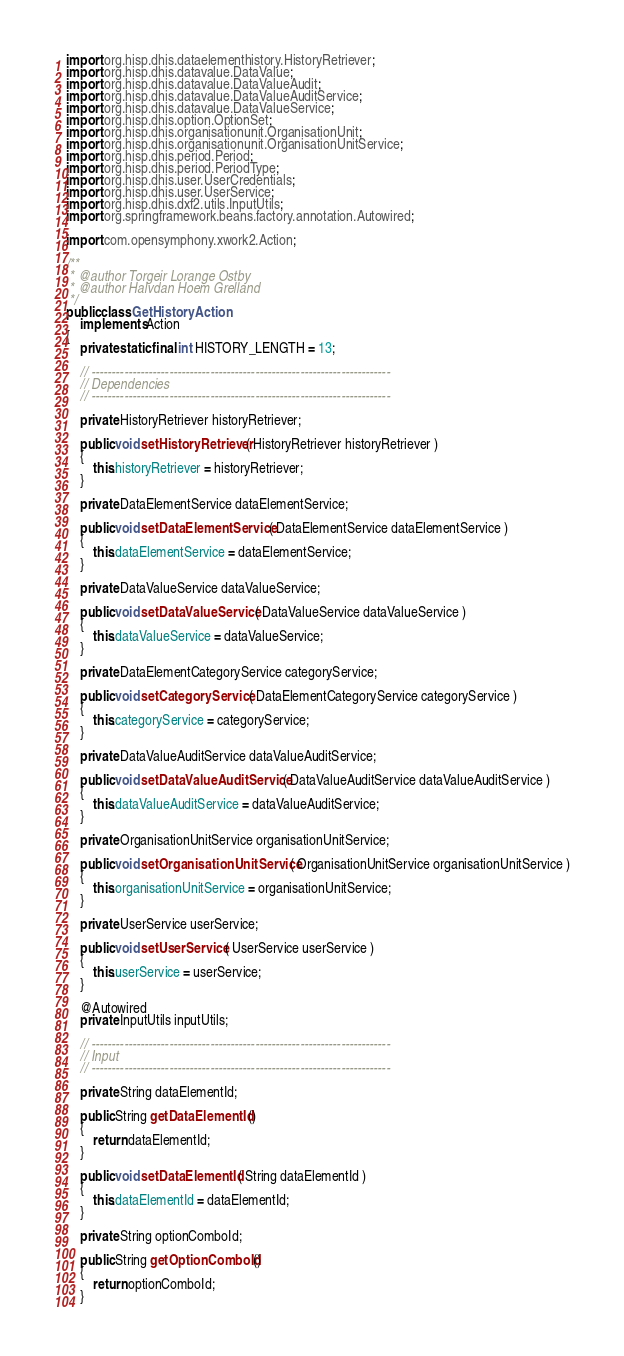Convert code to text. <code><loc_0><loc_0><loc_500><loc_500><_Java_>import org.hisp.dhis.dataelementhistory.HistoryRetriever;
import org.hisp.dhis.datavalue.DataValue;
import org.hisp.dhis.datavalue.DataValueAudit;
import org.hisp.dhis.datavalue.DataValueAuditService;
import org.hisp.dhis.datavalue.DataValueService;
import org.hisp.dhis.option.OptionSet;
import org.hisp.dhis.organisationunit.OrganisationUnit;
import org.hisp.dhis.organisationunit.OrganisationUnitService;
import org.hisp.dhis.period.Period;
import org.hisp.dhis.period.PeriodType;
import org.hisp.dhis.user.UserCredentials;
import org.hisp.dhis.user.UserService;
import org.hisp.dhis.dxf2.utils.InputUtils;
import org.springframework.beans.factory.annotation.Autowired;

import com.opensymphony.xwork2.Action;

/**
 * @author Torgeir Lorange Ostby
 * @author Halvdan Hoem Grelland
 */
public class GetHistoryAction
    implements Action
{
    private static final int HISTORY_LENGTH = 13;

    // -------------------------------------------------------------------------
    // Dependencies
    // -------------------------------------------------------------------------

    private HistoryRetriever historyRetriever;

    public void setHistoryRetriever( HistoryRetriever historyRetriever )
    {
        this.historyRetriever = historyRetriever;
    }

    private DataElementService dataElementService;

    public void setDataElementService( DataElementService dataElementService )
    {
        this.dataElementService = dataElementService;
    }

    private DataValueService dataValueService;

    public void setDataValueService( DataValueService dataValueService )
    {
        this.dataValueService = dataValueService;
    }

    private DataElementCategoryService categoryService;

    public void setCategoryService( DataElementCategoryService categoryService )
    {
        this.categoryService = categoryService;
    }

    private DataValueAuditService dataValueAuditService;

    public void setDataValueAuditService( DataValueAuditService dataValueAuditService )
    {
        this.dataValueAuditService = dataValueAuditService;
    }

    private OrganisationUnitService organisationUnitService;

    public void setOrganisationUnitService( OrganisationUnitService organisationUnitService )
    {
        this.organisationUnitService = organisationUnitService;
    }

    private UserService userService;

    public void setUserService( UserService userService )
    {
        this.userService = userService;
    }

    @Autowired
    private InputUtils inputUtils;

    // -------------------------------------------------------------------------
    // Input
    // -------------------------------------------------------------------------

    private String dataElementId;

    public String getDataElementId()
    {
        return dataElementId;
    }

    public void setDataElementId( String dataElementId )
    {
        this.dataElementId = dataElementId;
    }

    private String optionComboId;

    public String getOptionComboId()
    {
        return optionComboId;
    }
</code> 